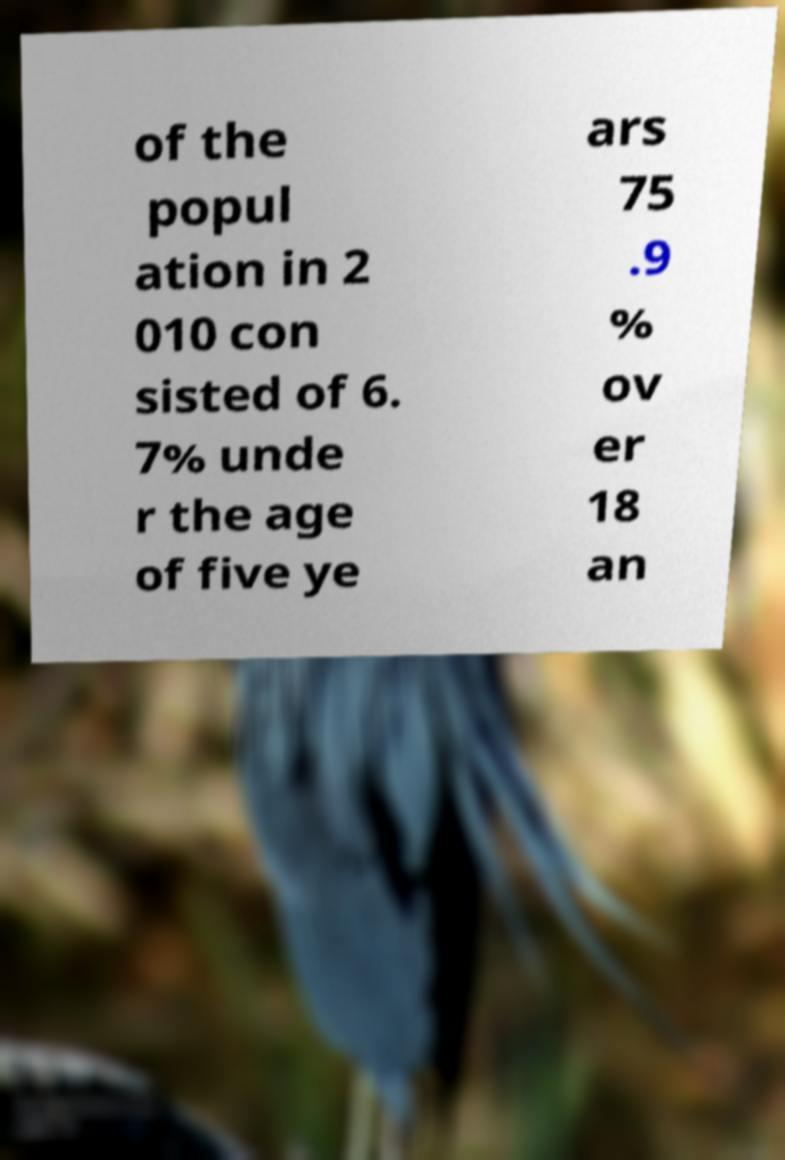Please read and relay the text visible in this image. What does it say? of the popul ation in 2 010 con sisted of 6. 7% unde r the age of five ye ars 75 .9 % ov er 18 an 